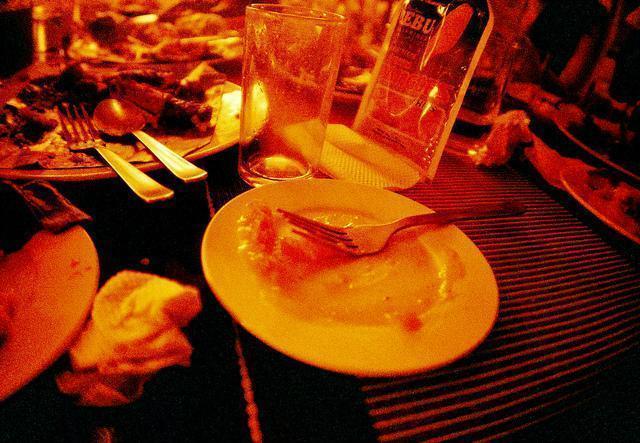Why would someone sit at this table?
Indicate the correct choice and explain in the format: 'Answer: answer
Rationale: rationale.'
Options: To eat, to work, to paint, to sew. Answer: to eat.
Rationale: It has dishes and food on it 